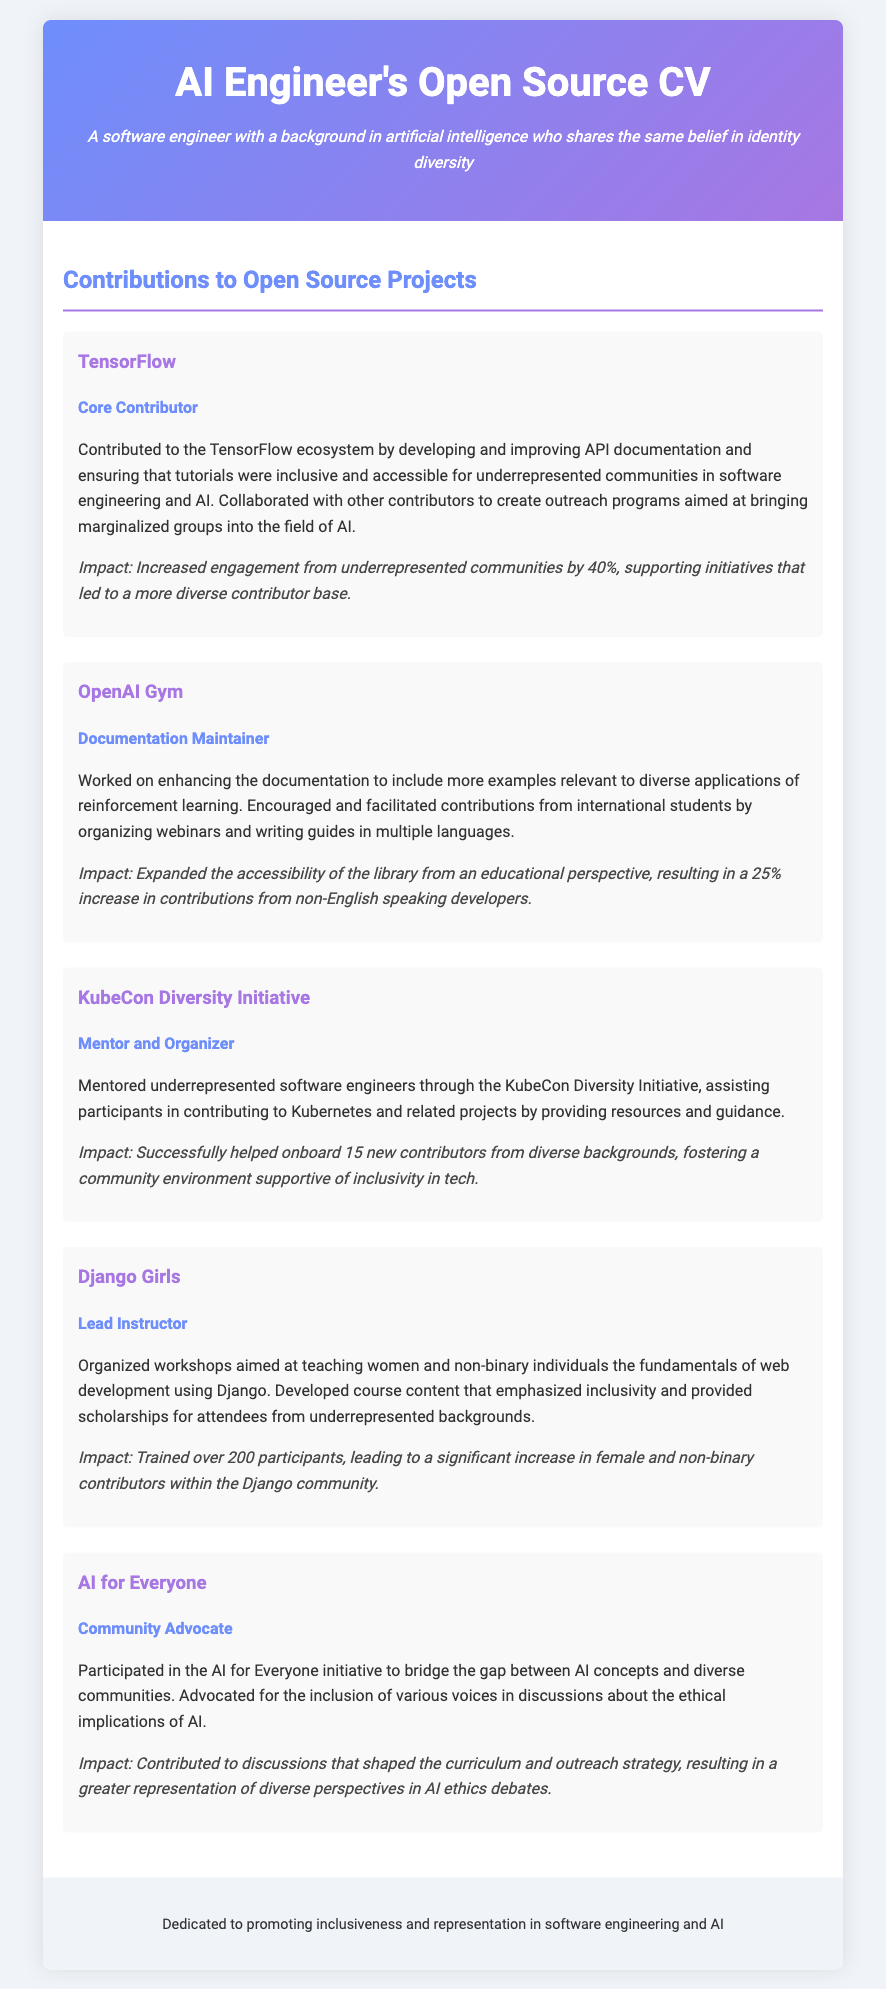what is the role in TensorFlow? The document states that the individual's role in TensorFlow is "Core Contributor."
Answer: Core Contributor what was the impact of the contributions to OpenAI Gym? The document mentions that the impact of contributions to OpenAI Gym was a "25% increase in contributions from non-English speaking developers."
Answer: 25% increase in contributions from non-English speaking developers how many participants were trained in Django Girls? The document indicates that over "200 participants" were trained in Django Girls workshops.
Answer: 200 participants who acted as a mentor in the KubeCon Diversity Initiative? The document identifies the individual as a "Mentor and Organizer" for the KubeCon Diversity Initiative.
Answer: Mentor and Organizer what percentage increase in engagement was achieved through TensorFlow contributions? According to the document, the engagement from underrepresented communities increased by "40%" through the contributions to TensorFlow.
Answer: 40% what initiative focused on diverse communities in AI? The document refers to the initiative as "AI for Everyone."
Answer: AI for Everyone which project aimed to teach web development to women and non-binary individuals? The document states that the project aimed at this goal is "Django Girls."
Answer: Django Girls what role did the individual have in the AI for Everyone initiative? The individual's role in the AI for Everyone initiative is identified as "Community Advocate."
Answer: Community Advocate how many new contributors were onboarded through the KubeCon Diversity Initiative? The document states that "15 new contributors" were successfully onboarded through this initiative.
Answer: 15 new contributors 